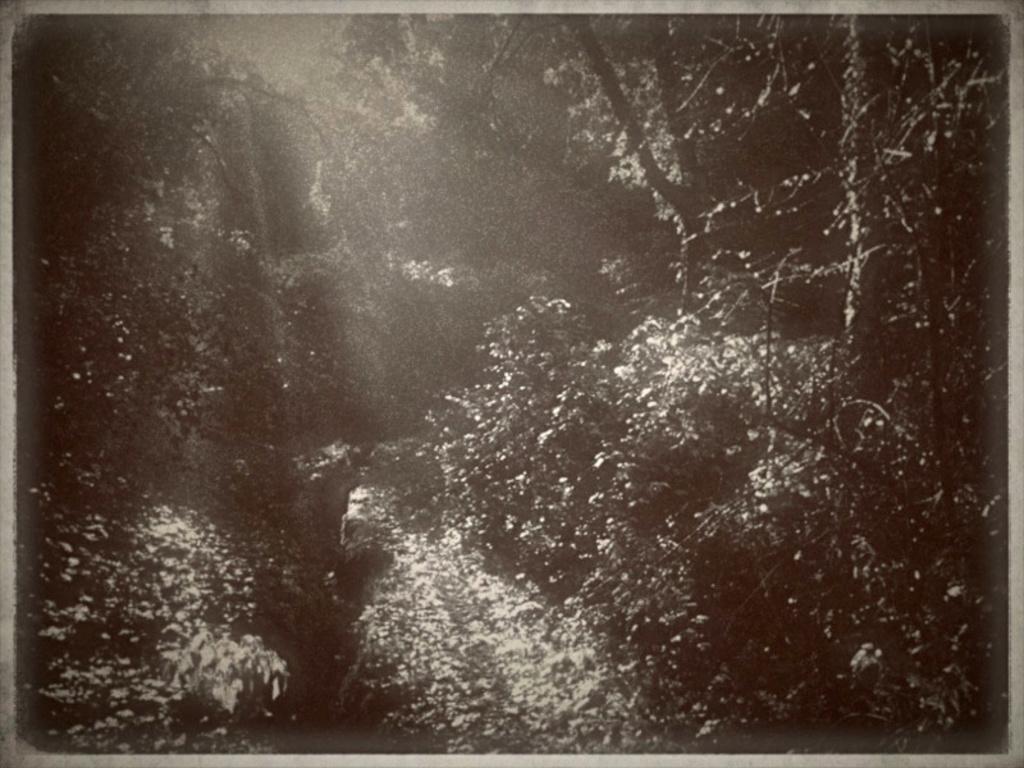Please provide a concise description of this image. I can see this is an edited image. Also I can see there are trees. 